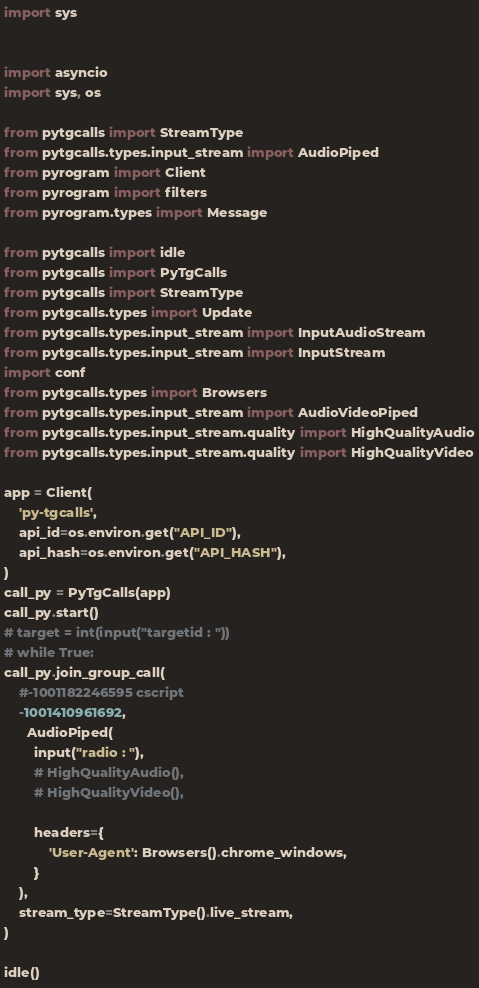<code> <loc_0><loc_0><loc_500><loc_500><_Python_>
import sys


import asyncio
import sys, os

from pytgcalls import StreamType
from pytgcalls.types.input_stream import AudioPiped
from pyrogram import Client
from pyrogram import filters
from pyrogram.types import Message

from pytgcalls import idle
from pytgcalls import PyTgCalls
from pytgcalls import StreamType
from pytgcalls.types import Update
from pytgcalls.types.input_stream import InputAudioStream
from pytgcalls.types.input_stream import InputStream
import conf
from pytgcalls.types import Browsers
from pytgcalls.types.input_stream import AudioVideoPiped
from pytgcalls.types.input_stream.quality import HighQualityAudio
from pytgcalls.types.input_stream.quality import HighQualityVideo

app = Client(
    'py-tgcalls',
    api_id=os.environ.get("API_ID"),
    api_hash=os.environ.get("API_HASH"),
)
call_py = PyTgCalls(app)
call_py.start()
# target = int(input("targetid : "))
# while True:
call_py.join_group_call(
    #-1001182246595 cscript
    -1001410961692, 
      AudioPiped(
        input("radio : "),
        # HighQualityAudio(),
        # HighQualityVideo(),
        
        headers={
            'User-Agent': Browsers().chrome_windows,
        }
    ),
    stream_type=StreamType().live_stream,
)

idle()
</code> 